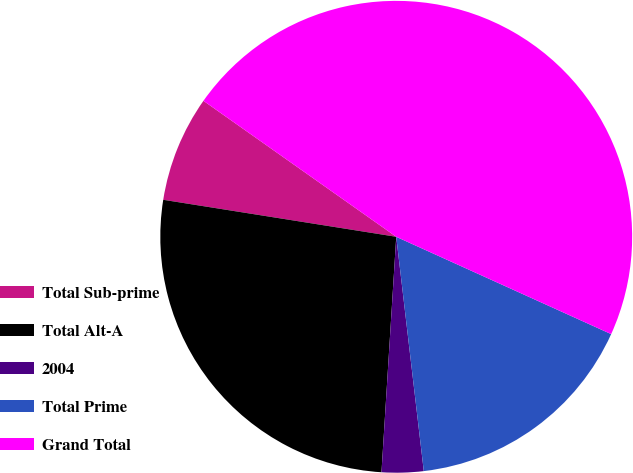Convert chart. <chart><loc_0><loc_0><loc_500><loc_500><pie_chart><fcel>Total Sub-prime<fcel>Total Alt-A<fcel>2004<fcel>Total Prime<fcel>Grand Total<nl><fcel>7.27%<fcel>26.51%<fcel>2.86%<fcel>16.37%<fcel>46.99%<nl></chart> 